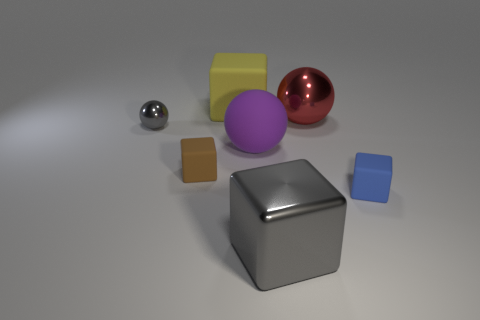What is the big cube in front of the big cube on the left side of the big gray thing made of?
Offer a very short reply. Metal. What size is the object in front of the tiny rubber block that is in front of the rubber block to the left of the big yellow thing?
Provide a succinct answer. Large. What is the material of the big red sphere?
Give a very brief answer. Metal. There is a rubber thing behind the gray metal ball; does it have the same size as the small gray thing?
Give a very brief answer. No. Is there a blue matte thing that has the same size as the brown rubber thing?
Make the answer very short. Yes. What color is the rubber cube that is right of the yellow matte block?
Keep it short and to the point. Blue. The metal thing that is both behind the purple sphere and on the right side of the small sphere has what shape?
Make the answer very short. Sphere. What number of tiny brown rubber things have the same shape as the big yellow rubber thing?
Your answer should be compact. 1. What number of tiny yellow matte spheres are there?
Your answer should be compact. 0. There is a matte cube that is both in front of the big purple thing and behind the small blue block; what is its size?
Your response must be concise. Small. 